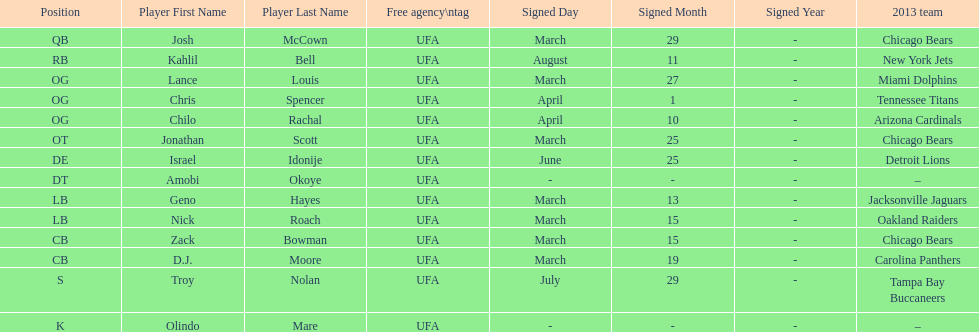How many free agents did this team pick up this season? 14. 